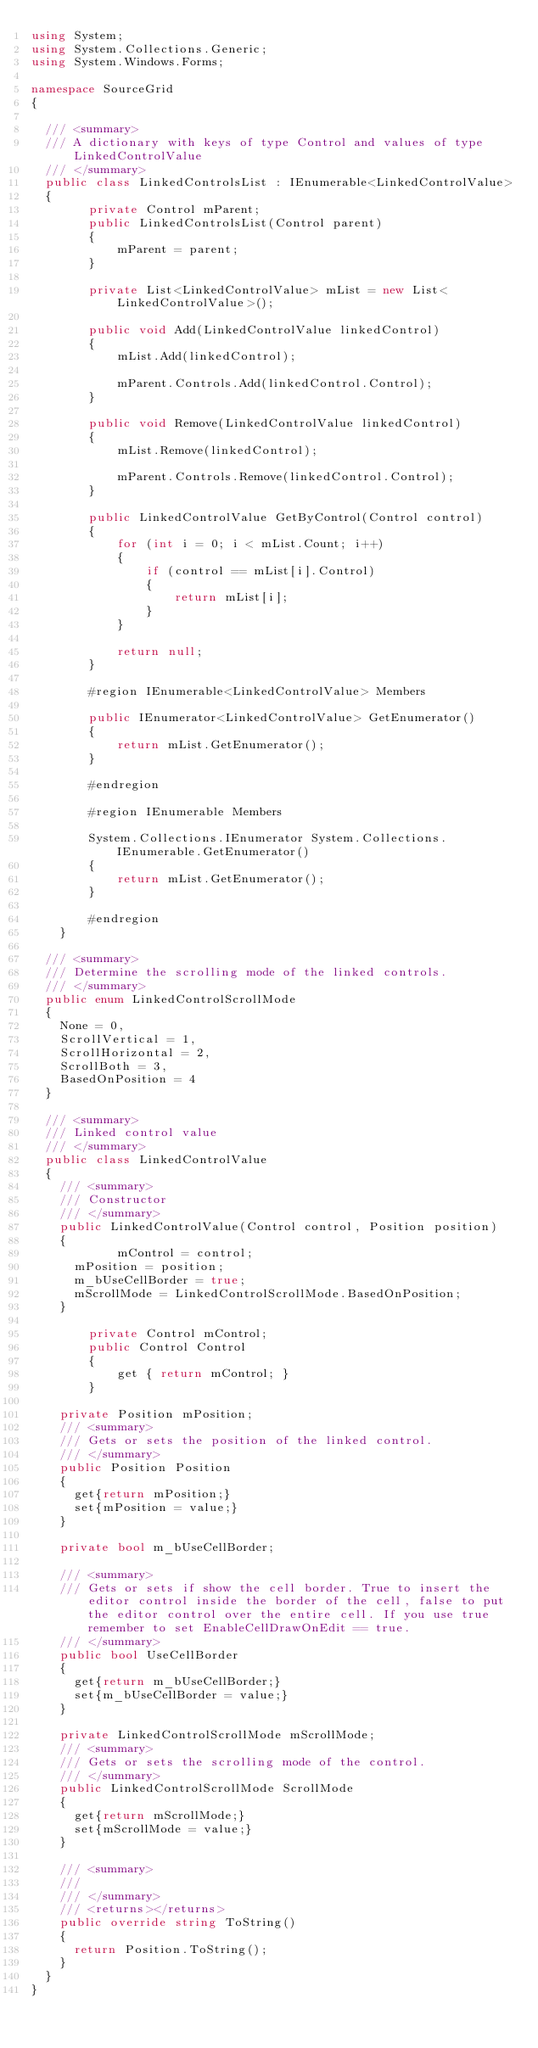<code> <loc_0><loc_0><loc_500><loc_500><_C#_>using System;
using System.Collections.Generic;
using System.Windows.Forms;

namespace SourceGrid
{

	/// <summary>
	/// A dictionary with keys of type Control and values of type LinkedControlValue
	/// </summary>
	public class LinkedControlsList : IEnumerable<LinkedControlValue>
	{
        private Control mParent;
        public LinkedControlsList(Control parent)
        {
            mParent = parent;
        }

        private List<LinkedControlValue> mList = new List<LinkedControlValue>();

        public void Add(LinkedControlValue linkedControl)
        {
            mList.Add(linkedControl);

            mParent.Controls.Add(linkedControl.Control);
        }

        public void Remove(LinkedControlValue linkedControl)
        {
            mList.Remove(linkedControl);

            mParent.Controls.Remove(linkedControl.Control);
        }

        public LinkedControlValue GetByControl(Control control)
        {
            for (int i = 0; i < mList.Count; i++)
            {
                if (control == mList[i].Control)
                {
                    return mList[i];
                }
            }

            return null;
        }

        #region IEnumerable<LinkedControlValue> Members

        public IEnumerator<LinkedControlValue> GetEnumerator()
        {
            return mList.GetEnumerator();
        }

        #endregion

        #region IEnumerable Members

        System.Collections.IEnumerator System.Collections.IEnumerable.GetEnumerator()
        {
            return mList.GetEnumerator();
        }

        #endregion
    }

	/// <summary>
	/// Determine the scrolling mode of the linked controls.
	/// </summary>
	public enum LinkedControlScrollMode
	{
		None = 0,
		ScrollVertical = 1,
		ScrollHorizontal = 2,
		ScrollBoth = 3,
		BasedOnPosition = 4
	}

	/// <summary>
	/// Linked control value
	/// </summary>
	public class LinkedControlValue
	{
		/// <summary>
		/// Constructor
		/// </summary>
		public LinkedControlValue(Control control, Position position)
		{
            mControl = control;
			mPosition = position;
			m_bUseCellBorder = true;
			mScrollMode = LinkedControlScrollMode.BasedOnPosition;
		}

        private Control mControl;
        public Control Control
        {
            get { return mControl; }
        }

		private Position mPosition;
		/// <summary>
		/// Gets or sets the position of the linked control.
		/// </summary>
		public Position Position
		{
			get{return mPosition;}
			set{mPosition = value;}
		}

		private bool m_bUseCellBorder;

		/// <summary>
		/// Gets or sets if show the cell border. True to insert the editor control inside the border of the cell, false to put the editor control over the entire cell. If you use true remember to set EnableCellDrawOnEdit == true.
		/// </summary>
		public bool UseCellBorder
		{
			get{return m_bUseCellBorder;}
			set{m_bUseCellBorder = value;}
		}

		private LinkedControlScrollMode mScrollMode;
		/// <summary>
		/// Gets or sets the scrolling mode of the control.
		/// </summary>
		public LinkedControlScrollMode ScrollMode
		{
			get{return mScrollMode;}
			set{mScrollMode = value;}
		}

		/// <summary>
		/// 
		/// </summary>
		/// <returns></returns>
		public override string ToString()
		{
			return Position.ToString();
		}	
	}
}
</code> 